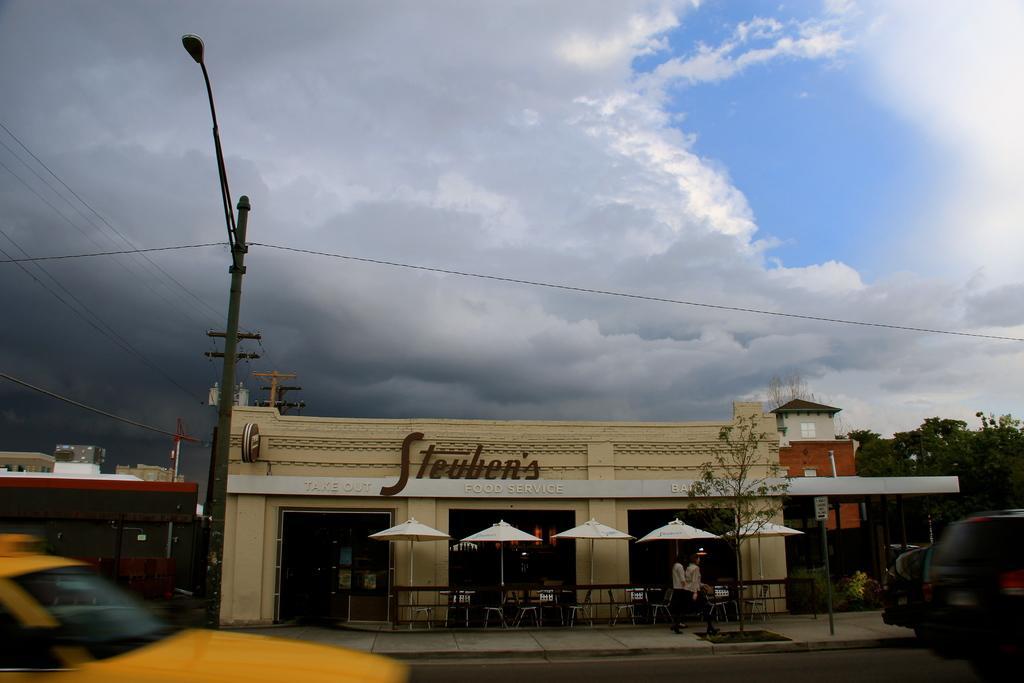Please provide a concise description of this image. In this picture we can see few buildings, pole, cables and vehicles, in front of building we can find few chairs, tables, umbrellas and group of people, in the background we can see few trees and clouds. 